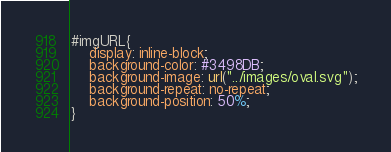<code> <loc_0><loc_0><loc_500><loc_500><_CSS_>

#imgURL{
    display: inline-block;
    background-color: #3498DB;
    background-image: url("../images/oval.svg");
    background-repeat: no-repeat;
    background-position: 50%;
}</code> 